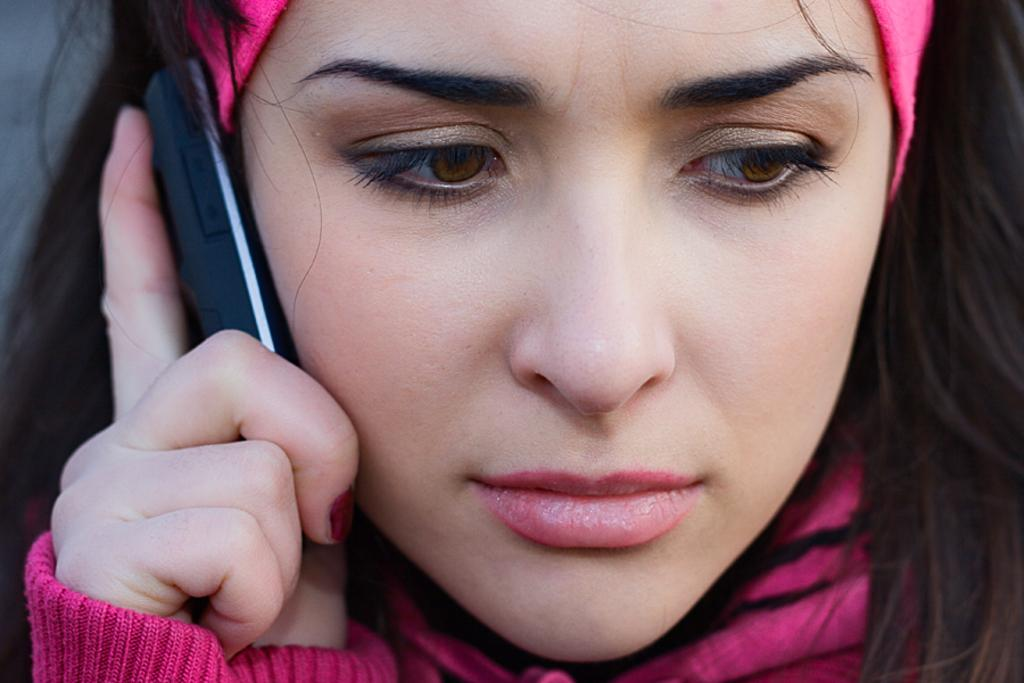What is the main subject of the image? There is a person in the image. What is the person holding in her hand? The person is holding a mobile in her hand. What type of holiday is the person celebrating in the image? There is no indication of a holiday in the image; it only shows a person holding a mobile. 